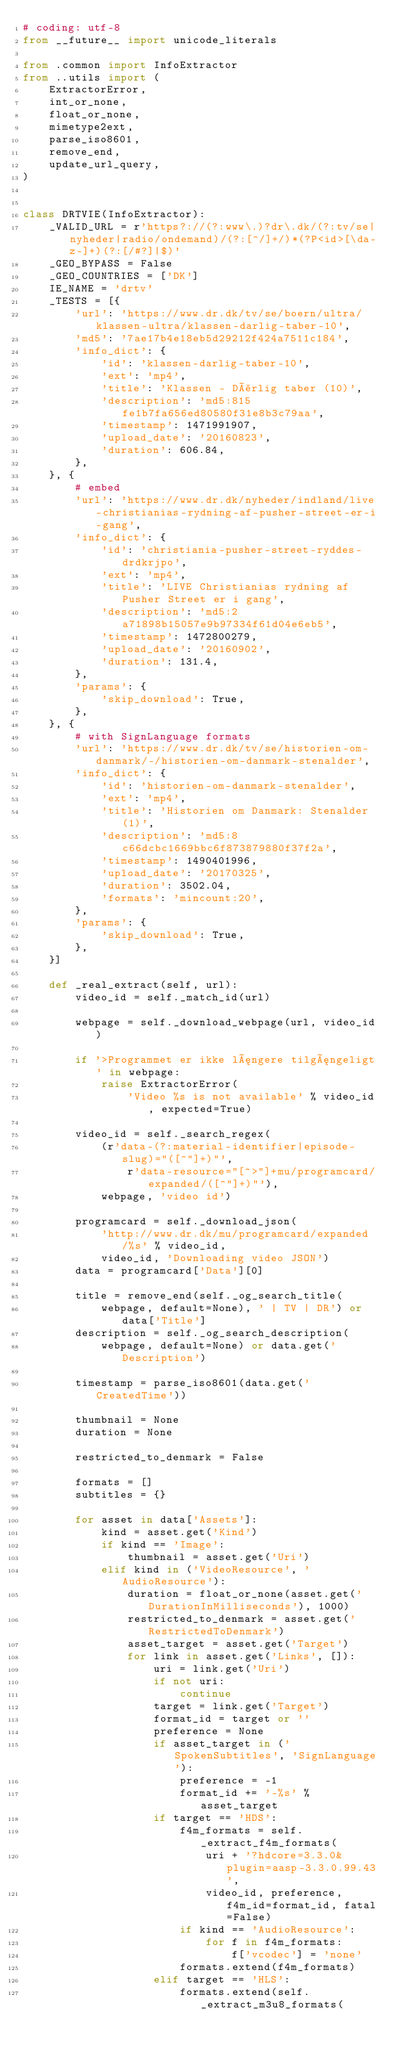<code> <loc_0><loc_0><loc_500><loc_500><_Python_># coding: utf-8
from __future__ import unicode_literals

from .common import InfoExtractor
from ..utils import (
    ExtractorError,
    int_or_none,
    float_or_none,
    mimetype2ext,
    parse_iso8601,
    remove_end,
    update_url_query,
)


class DRTVIE(InfoExtractor):
    _VALID_URL = r'https?://(?:www\.)?dr\.dk/(?:tv/se|nyheder|radio/ondemand)/(?:[^/]+/)*(?P<id>[\da-z-]+)(?:[/#?]|$)'
    _GEO_BYPASS = False
    _GEO_COUNTRIES = ['DK']
    IE_NAME = 'drtv'
    _TESTS = [{
        'url': 'https://www.dr.dk/tv/se/boern/ultra/klassen-ultra/klassen-darlig-taber-10',
        'md5': '7ae17b4e18eb5d29212f424a7511c184',
        'info_dict': {
            'id': 'klassen-darlig-taber-10',
            'ext': 'mp4',
            'title': 'Klassen - Dårlig taber (10)',
            'description': 'md5:815fe1b7fa656ed80580f31e8b3c79aa',
            'timestamp': 1471991907,
            'upload_date': '20160823',
            'duration': 606.84,
        },
    }, {
        # embed
        'url': 'https://www.dr.dk/nyheder/indland/live-christianias-rydning-af-pusher-street-er-i-gang',
        'info_dict': {
            'id': 'christiania-pusher-street-ryddes-drdkrjpo',
            'ext': 'mp4',
            'title': 'LIVE Christianias rydning af Pusher Street er i gang',
            'description': 'md5:2a71898b15057e9b97334f61d04e6eb5',
            'timestamp': 1472800279,
            'upload_date': '20160902',
            'duration': 131.4,
        },
        'params': {
            'skip_download': True,
        },
    }, {
        # with SignLanguage formats
        'url': 'https://www.dr.dk/tv/se/historien-om-danmark/-/historien-om-danmark-stenalder',
        'info_dict': {
            'id': 'historien-om-danmark-stenalder',
            'ext': 'mp4',
            'title': 'Historien om Danmark: Stenalder (1)',
            'description': 'md5:8c66dcbc1669bbc6f873879880f37f2a',
            'timestamp': 1490401996,
            'upload_date': '20170325',
            'duration': 3502.04,
            'formats': 'mincount:20',
        },
        'params': {
            'skip_download': True,
        },
    }]

    def _real_extract(self, url):
        video_id = self._match_id(url)

        webpage = self._download_webpage(url, video_id)

        if '>Programmet er ikke længere tilgængeligt' in webpage:
            raise ExtractorError(
                'Video %s is not available' % video_id, expected=True)

        video_id = self._search_regex(
            (r'data-(?:material-identifier|episode-slug)="([^"]+)"',
                r'data-resource="[^>"]+mu/programcard/expanded/([^"]+)"'),
            webpage, 'video id')

        programcard = self._download_json(
            'http://www.dr.dk/mu/programcard/expanded/%s' % video_id,
            video_id, 'Downloading video JSON')
        data = programcard['Data'][0]

        title = remove_end(self._og_search_title(
            webpage, default=None), ' | TV | DR') or data['Title']
        description = self._og_search_description(
            webpage, default=None) or data.get('Description')

        timestamp = parse_iso8601(data.get('CreatedTime'))

        thumbnail = None
        duration = None

        restricted_to_denmark = False

        formats = []
        subtitles = {}

        for asset in data['Assets']:
            kind = asset.get('Kind')
            if kind == 'Image':
                thumbnail = asset.get('Uri')
            elif kind in ('VideoResource', 'AudioResource'):
                duration = float_or_none(asset.get('DurationInMilliseconds'), 1000)
                restricted_to_denmark = asset.get('RestrictedToDenmark')
                asset_target = asset.get('Target')
                for link in asset.get('Links', []):
                    uri = link.get('Uri')
                    if not uri:
                        continue
                    target = link.get('Target')
                    format_id = target or ''
                    preference = None
                    if asset_target in ('SpokenSubtitles', 'SignLanguage'):
                        preference = -1
                        format_id += '-%s' % asset_target
                    if target == 'HDS':
                        f4m_formats = self._extract_f4m_formats(
                            uri + '?hdcore=3.3.0&plugin=aasp-3.3.0.99.43',
                            video_id, preference, f4m_id=format_id, fatal=False)
                        if kind == 'AudioResource':
                            for f in f4m_formats:
                                f['vcodec'] = 'none'
                        formats.extend(f4m_formats)
                    elif target == 'HLS':
                        formats.extend(self._extract_m3u8_formats(</code> 